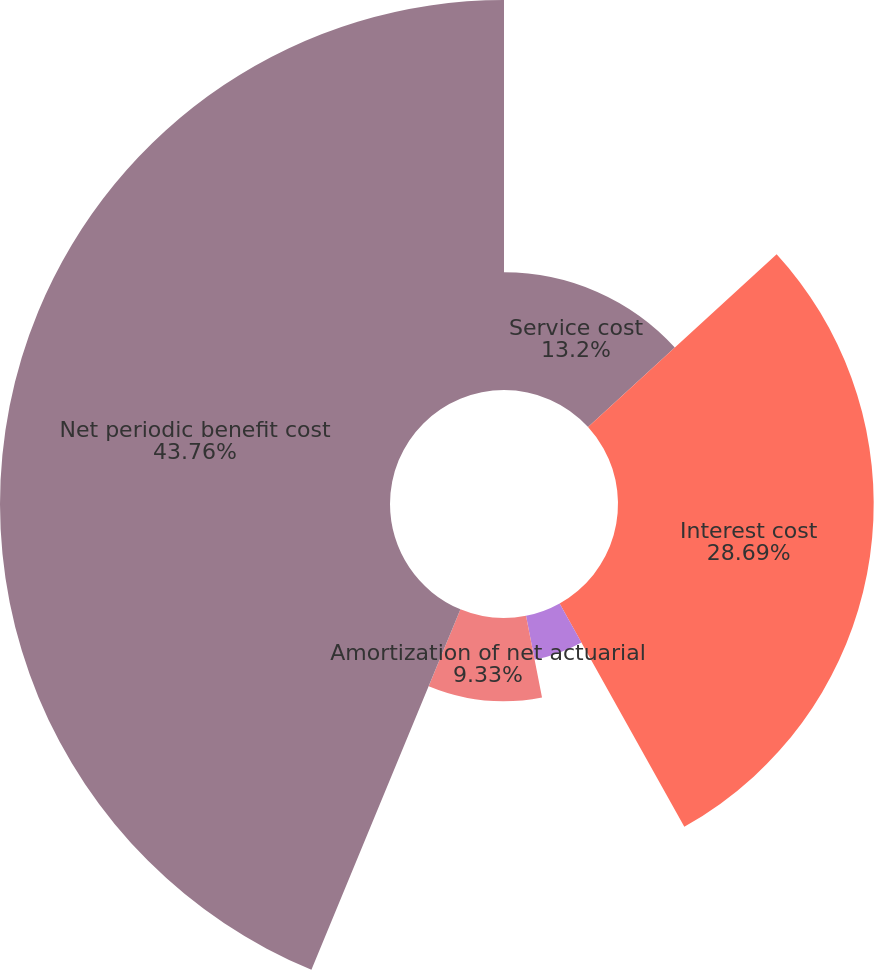Convert chart to OTSL. <chart><loc_0><loc_0><loc_500><loc_500><pie_chart><fcel>Service cost<fcel>Interest cost<fcel>Amortization of prior service<fcel>Amortization of net actuarial<fcel>Net periodic benefit cost<nl><fcel>13.2%<fcel>28.69%<fcel>5.02%<fcel>9.33%<fcel>43.76%<nl></chart> 